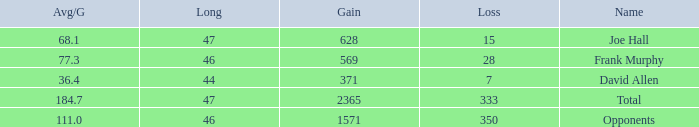What is the average gain per game for those with a gain less than 1571 and a long less than 46? 1.0. 